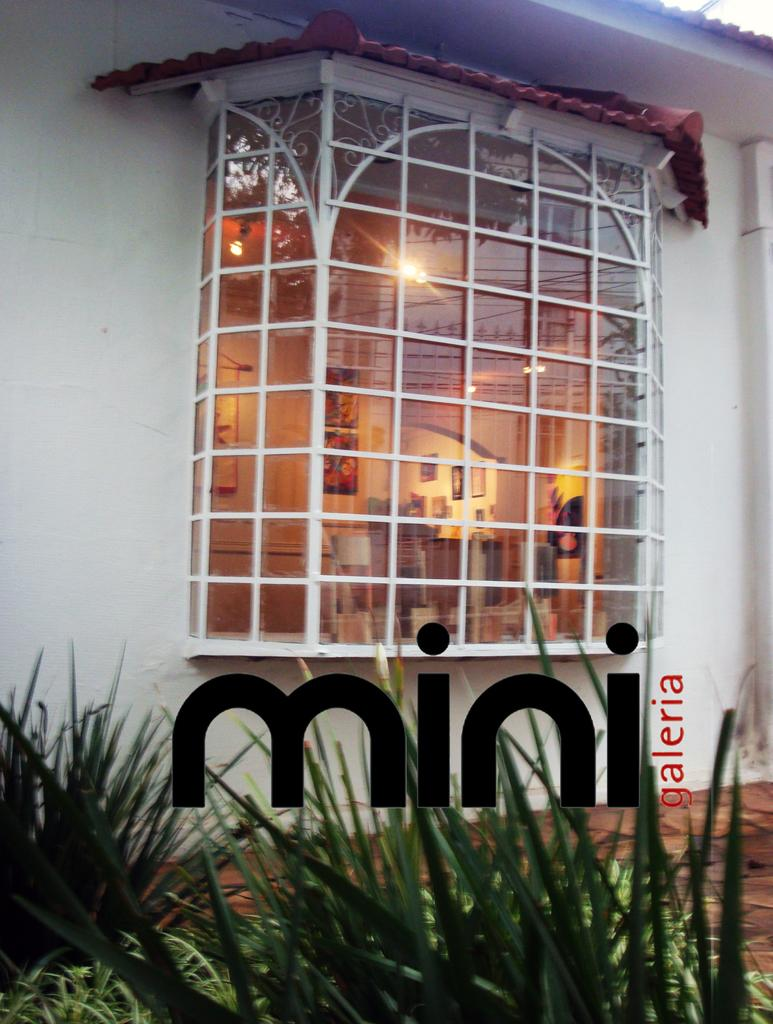What is present in the image that allows for a view of a room? There is a window in the image that provides a view of a room. What can be observed about the walls in the room? The walls in the room are white. What type of vegetation is visible at the bottom of the image? There are plants visible at the bottom of the image. Can you describe any additional features of the image? The image contains a watermark. What hobbies do the girls in the image have? There are no girls present in the image, so it is not possible to determine their hobbies. What type of cactus can be seen in the image? There is no cactus present in the image. 